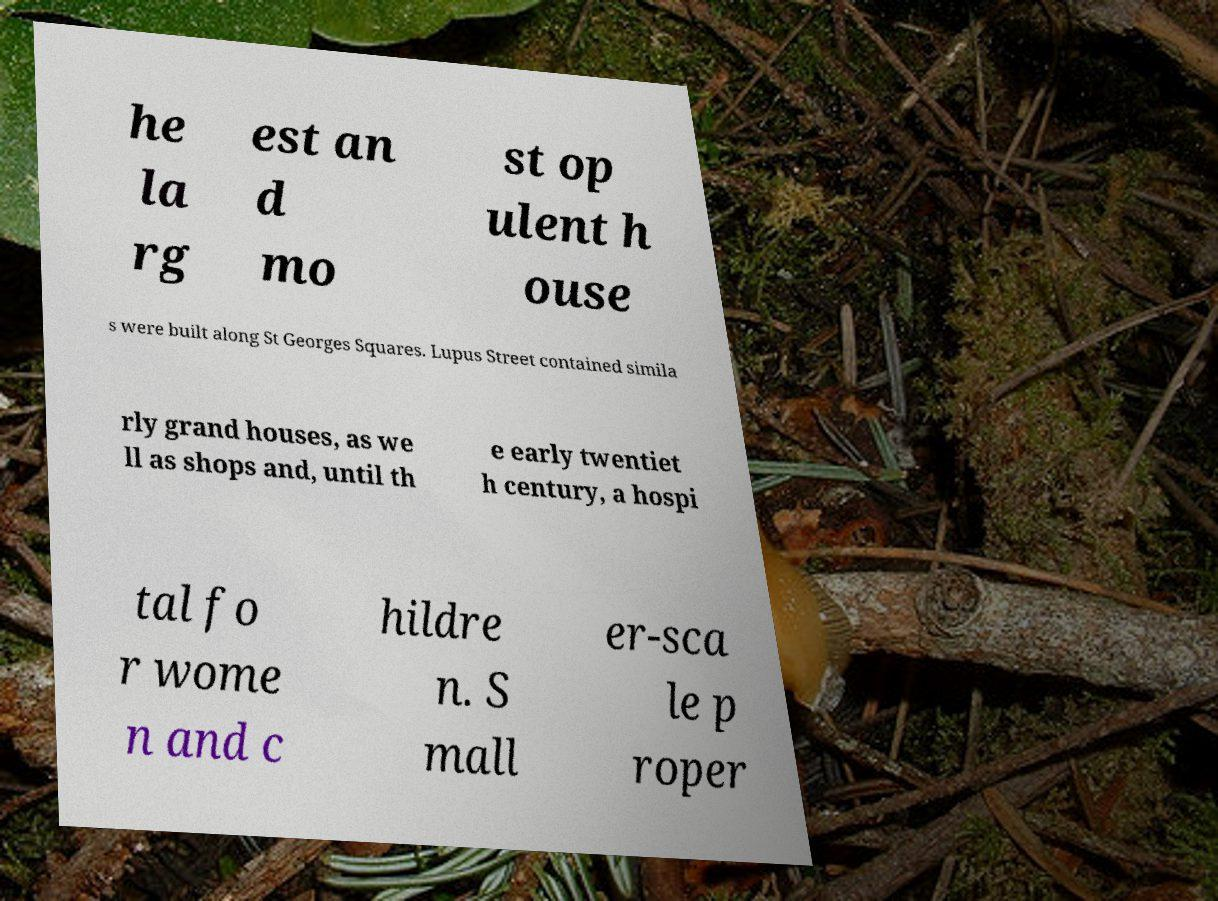Please read and relay the text visible in this image. What does it say? he la rg est an d mo st op ulent h ouse s were built along St Georges Squares. Lupus Street contained simila rly grand houses, as we ll as shops and, until th e early twentiet h century, a hospi tal fo r wome n and c hildre n. S mall er-sca le p roper 